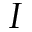Convert formula to latex. <formula><loc_0><loc_0><loc_500><loc_500>I</formula> 